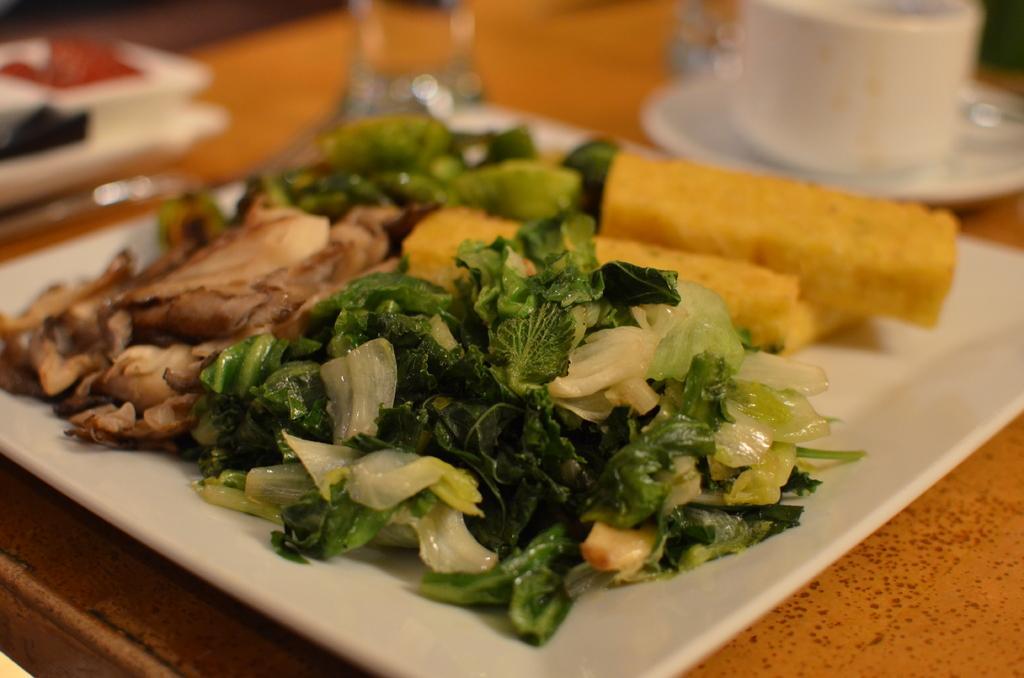Could you give a brief overview of what you see in this image? In center of this picture we can see the platters containing the food items and we can see a cup with a saucer and some other items are placed on the top of the table. 